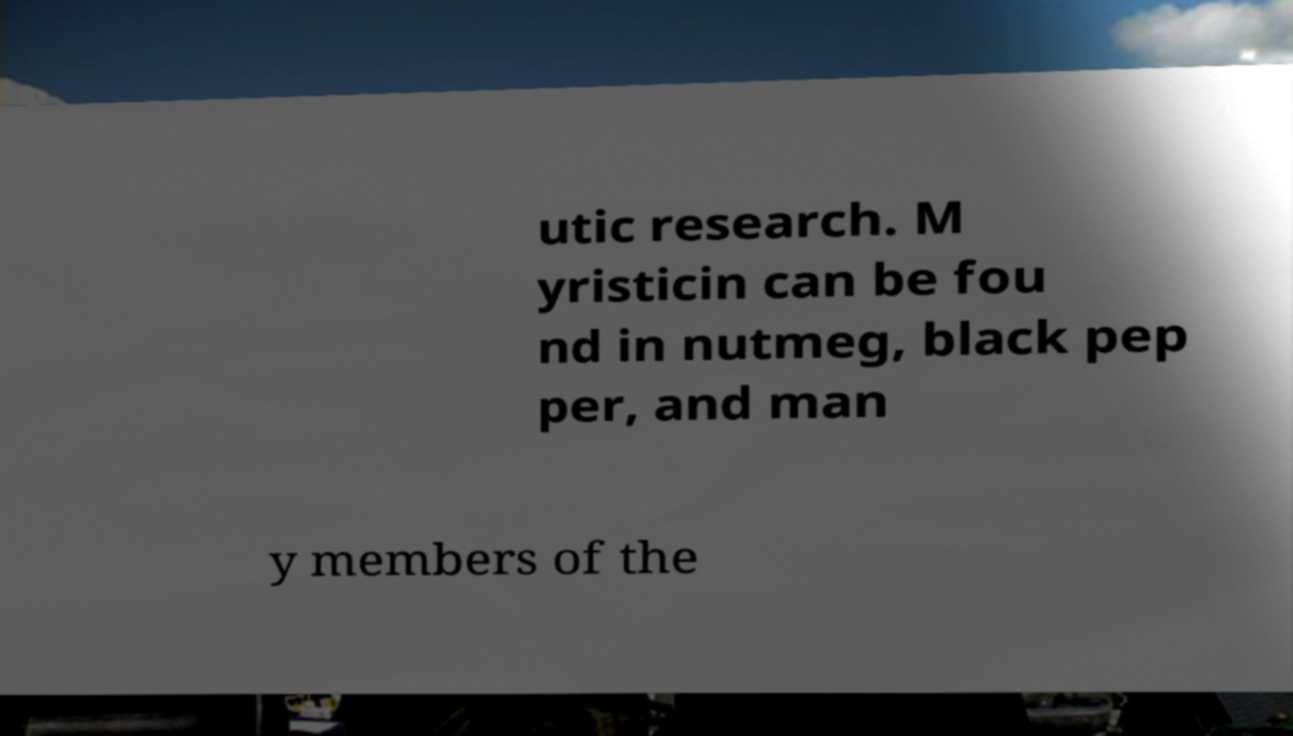Please identify and transcribe the text found in this image. utic research. M yristicin can be fou nd in nutmeg, black pep per, and man y members of the 